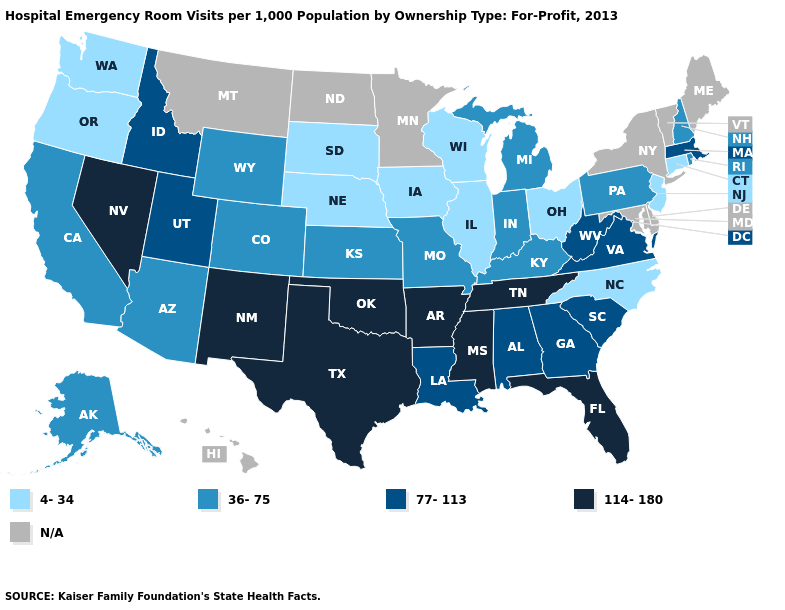What is the highest value in the USA?
Short answer required. 114-180. Among the states that border Idaho , which have the lowest value?
Keep it brief. Oregon, Washington. What is the value of Louisiana?
Concise answer only. 77-113. Name the states that have a value in the range 114-180?
Answer briefly. Arkansas, Florida, Mississippi, Nevada, New Mexico, Oklahoma, Tennessee, Texas. What is the value of South Carolina?
Be succinct. 77-113. Which states have the lowest value in the South?
Concise answer only. North Carolina. What is the value of Rhode Island?
Quick response, please. 36-75. Name the states that have a value in the range 4-34?
Keep it brief. Connecticut, Illinois, Iowa, Nebraska, New Jersey, North Carolina, Ohio, Oregon, South Dakota, Washington, Wisconsin. Which states have the lowest value in the USA?
Concise answer only. Connecticut, Illinois, Iowa, Nebraska, New Jersey, North Carolina, Ohio, Oregon, South Dakota, Washington, Wisconsin. Name the states that have a value in the range 114-180?
Concise answer only. Arkansas, Florida, Mississippi, Nevada, New Mexico, Oklahoma, Tennessee, Texas. What is the value of Massachusetts?
Give a very brief answer. 77-113. How many symbols are there in the legend?
Write a very short answer. 5. What is the lowest value in states that border Michigan?
Concise answer only. 4-34. 